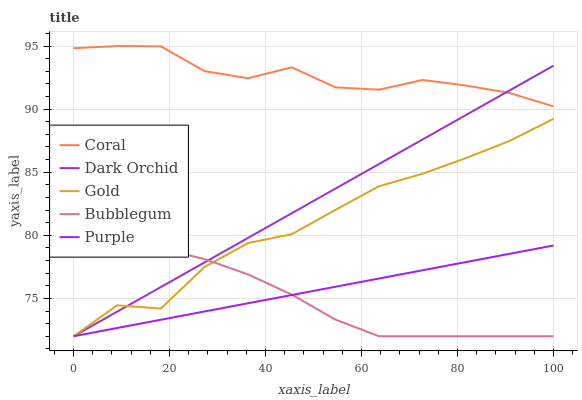Does Coral have the minimum area under the curve?
Answer yes or no. No. Does Bubblegum have the maximum area under the curve?
Answer yes or no. No. Is Coral the smoothest?
Answer yes or no. No. Is Coral the roughest?
Answer yes or no. No. Does Coral have the lowest value?
Answer yes or no. No. Does Bubblegum have the highest value?
Answer yes or no. No. Is Gold less than Coral?
Answer yes or no. Yes. Is Coral greater than Gold?
Answer yes or no. Yes. Does Gold intersect Coral?
Answer yes or no. No. 